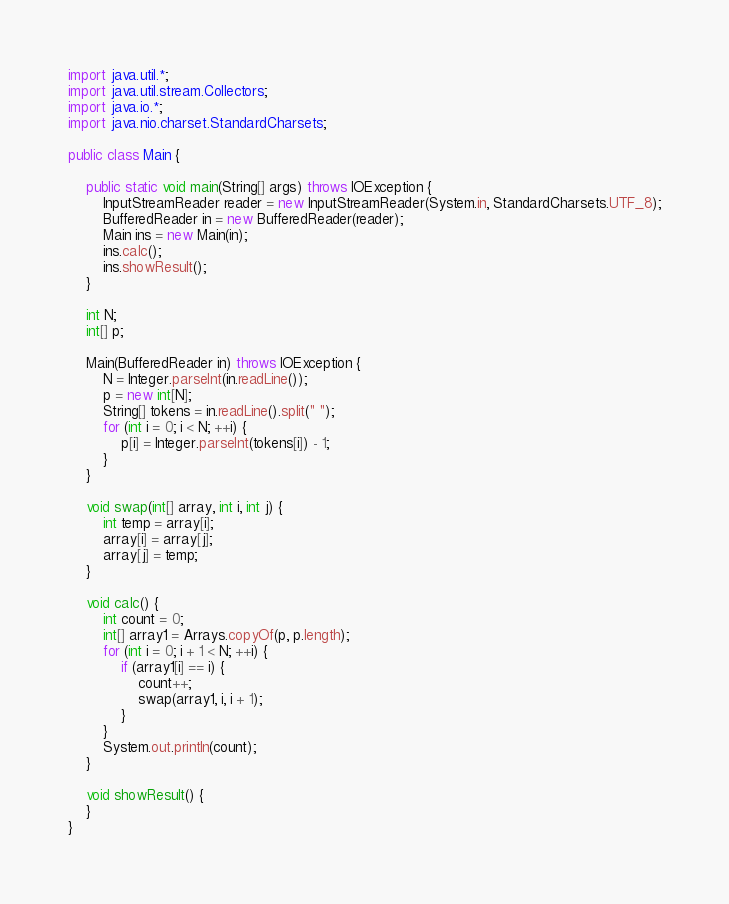Convert code to text. <code><loc_0><loc_0><loc_500><loc_500><_Java_>import java.util.*;
import java.util.stream.Collectors;
import java.io.*;
import java.nio.charset.StandardCharsets;

public class Main {

	public static void main(String[] args) throws IOException {
		InputStreamReader reader = new InputStreamReader(System.in, StandardCharsets.UTF_8);
		BufferedReader in = new BufferedReader(reader);
		Main ins = new Main(in);
		ins.calc();
		ins.showResult();
	}

	int N;
	int[] p;

	Main(BufferedReader in) throws IOException {
		N = Integer.parseInt(in.readLine());
		p = new int[N];
		String[] tokens = in.readLine().split(" ");
		for (int i = 0; i < N; ++i) {
			p[i] = Integer.parseInt(tokens[i]) - 1;
		}
	}

	void swap(int[] array, int i, int j) {
		int temp = array[i];
		array[i] = array[j];
		array[j] = temp;
	}

	void calc() {
		int count = 0;
		int[] array1 = Arrays.copyOf(p, p.length);
		for (int i = 0; i + 1 < N; ++i) {
			if (array1[i] == i) {
				count++;
				swap(array1, i, i + 1);
			}
		}
		System.out.println(count);
	}

	void showResult() {
	}
}</code> 